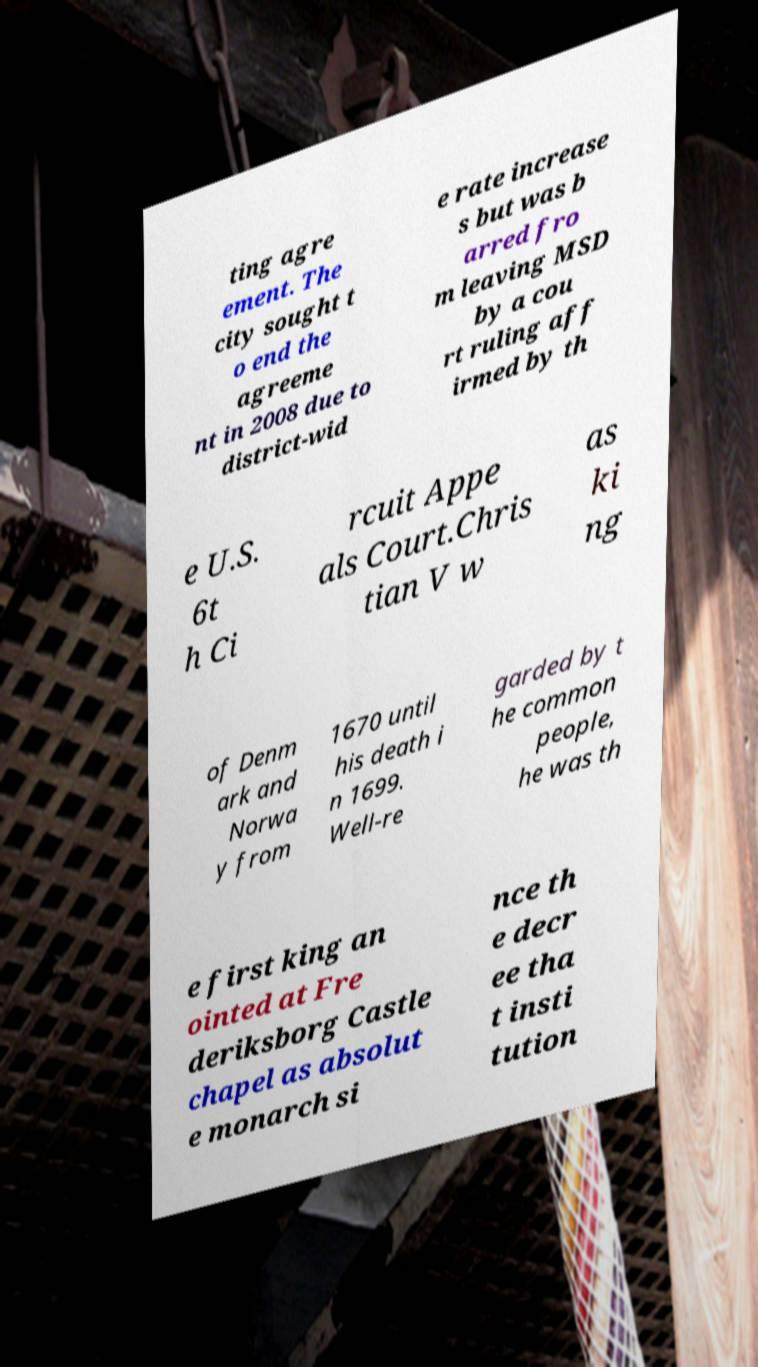Can you accurately transcribe the text from the provided image for me? ting agre ement. The city sought t o end the agreeme nt in 2008 due to district-wid e rate increase s but was b arred fro m leaving MSD by a cou rt ruling aff irmed by th e U.S. 6t h Ci rcuit Appe als Court.Chris tian V w as ki ng of Denm ark and Norwa y from 1670 until his death i n 1699. Well-re garded by t he common people, he was th e first king an ointed at Fre deriksborg Castle chapel as absolut e monarch si nce th e decr ee tha t insti tution 